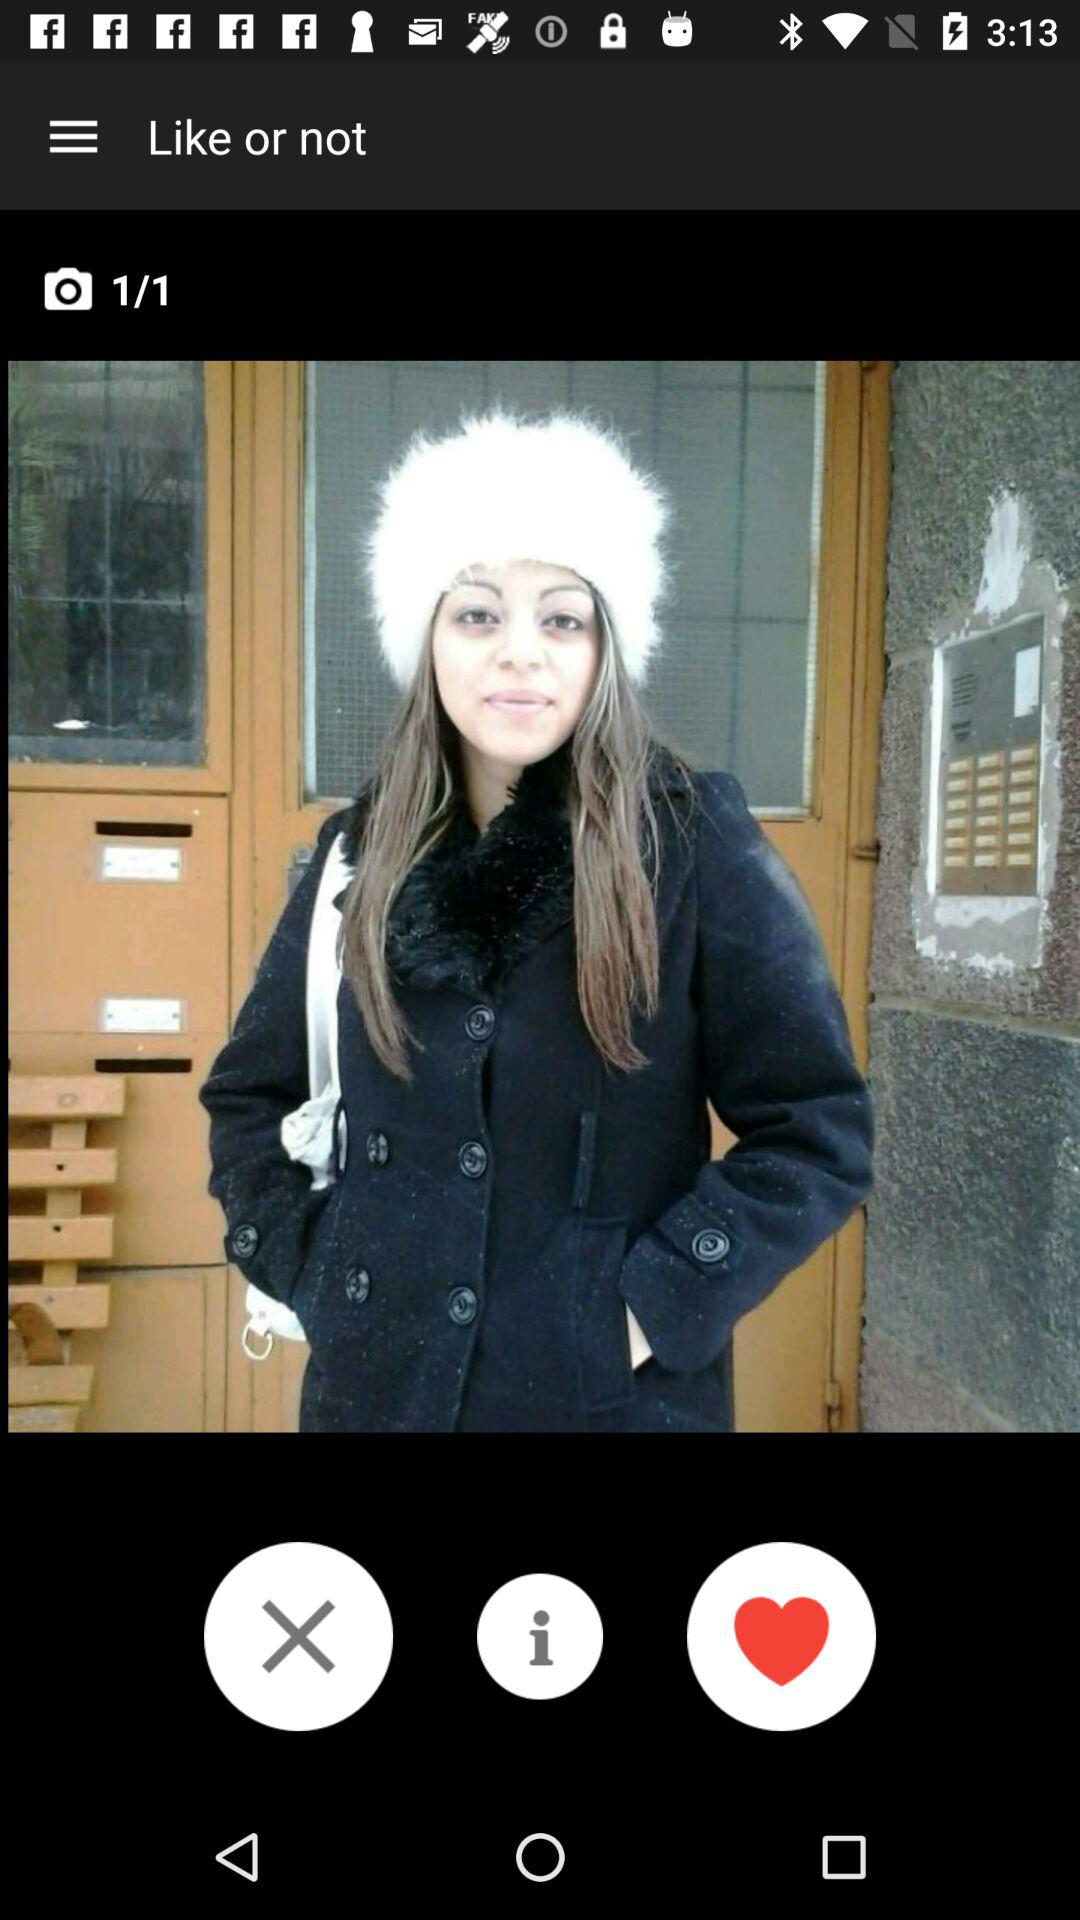How many comments are on the photo?
When the provided information is insufficient, respond with <no answer>. <no answer> 